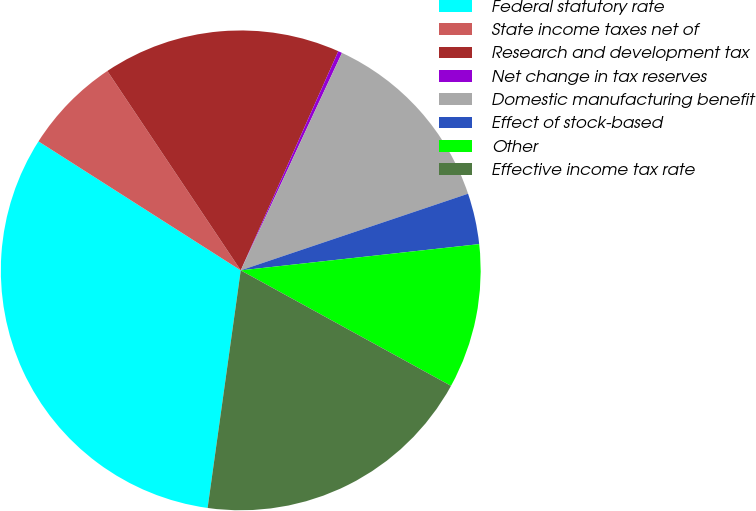Convert chart. <chart><loc_0><loc_0><loc_500><loc_500><pie_chart><fcel>Federal statutory rate<fcel>State income taxes net of<fcel>Research and development tax<fcel>Net change in tax reserves<fcel>Domestic manufacturing benefit<fcel>Effect of stock-based<fcel>Other<fcel>Effective income tax rate<nl><fcel>31.83%<fcel>6.58%<fcel>16.05%<fcel>0.27%<fcel>12.89%<fcel>3.43%<fcel>9.74%<fcel>19.21%<nl></chart> 